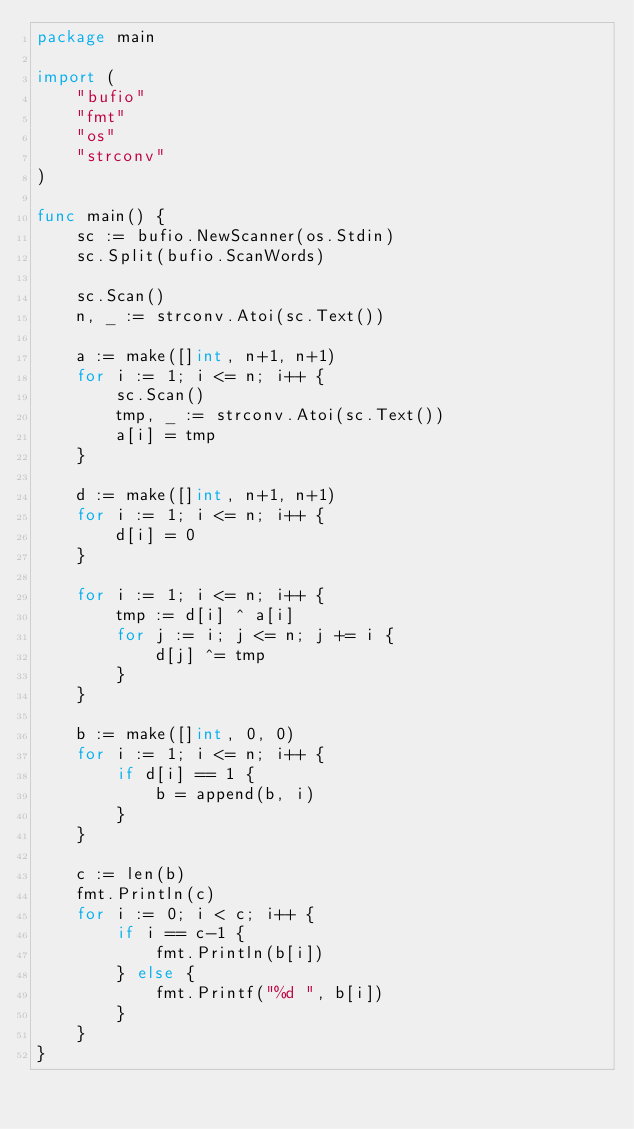Convert code to text. <code><loc_0><loc_0><loc_500><loc_500><_Go_>package main

import (
	"bufio"
	"fmt"
	"os"
	"strconv"
)

func main() {
	sc := bufio.NewScanner(os.Stdin)
	sc.Split(bufio.ScanWords)

	sc.Scan()
	n, _ := strconv.Atoi(sc.Text())

	a := make([]int, n+1, n+1)
	for i := 1; i <= n; i++ {
		sc.Scan()
		tmp, _ := strconv.Atoi(sc.Text())
		a[i] = tmp
	}

	d := make([]int, n+1, n+1)
	for i := 1; i <= n; i++ {
		d[i] = 0
	}

	for i := 1; i <= n; i++ {
		tmp := d[i] ^ a[i]
		for j := i; j <= n; j += i {
			d[j] ^= tmp
		}
	}

	b := make([]int, 0, 0)
	for i := 1; i <= n; i++ {
		if d[i] == 1 {
			b = append(b, i)
		}
	}

	c := len(b)
	fmt.Println(c)
	for i := 0; i < c; i++ {
		if i == c-1 {
			fmt.Println(b[i])
		} else {
			fmt.Printf("%d ", b[i])
		}
	}
}
</code> 